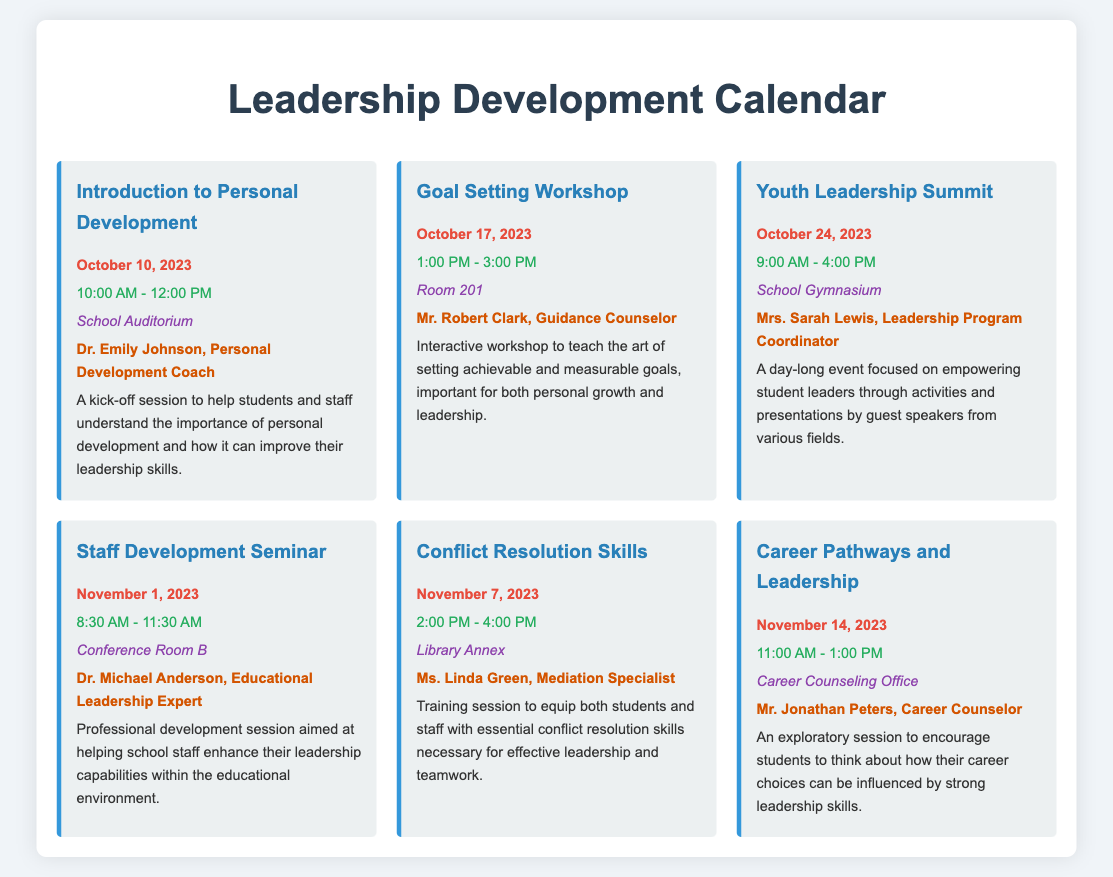what is the date for the Youth Leadership Summit? The Youth Leadership Summit is scheduled for October 24, 2023, as stated in the document.
Answer: October 24, 2023 who is facilitating the Goal Setting Workshop? The facilitator for the Goal Setting Workshop is Mr. Robert Clark, which is mentioned in the event details.
Answer: Mr. Robert Clark what time does the Conflict Resolution Skills session start? The Conflict Resolution Skills session starts at 2:00 PM, as indicated in the time section of the event.
Answer: 2:00 PM how many hours is the Staff Development Seminar? The Staff Development Seminar runs for 3 hours, from 8:30 AM to 11:30 AM.
Answer: 3 hours what is the main focus of the Introduction to Personal Development session? The session focuses on helping students and staff understand the importance of personal development and its impact on leadership skills.
Answer: Importance of personal development which room will host the Goal Setting Workshop? The Goal Setting Workshop will take place in Room 201, as noted in the location details.
Answer: Room 201 what is the total duration of the Youth Leadership Summit? The Youth Leadership Summit lasts for 7 hours, from 9:00 AM to 4:00 PM.
Answer: 7 hours which event is scheduled for November 14, 2023? The event on November 14, 2023, is the Career Pathways and Leadership session.
Answer: Career Pathways and Leadership 